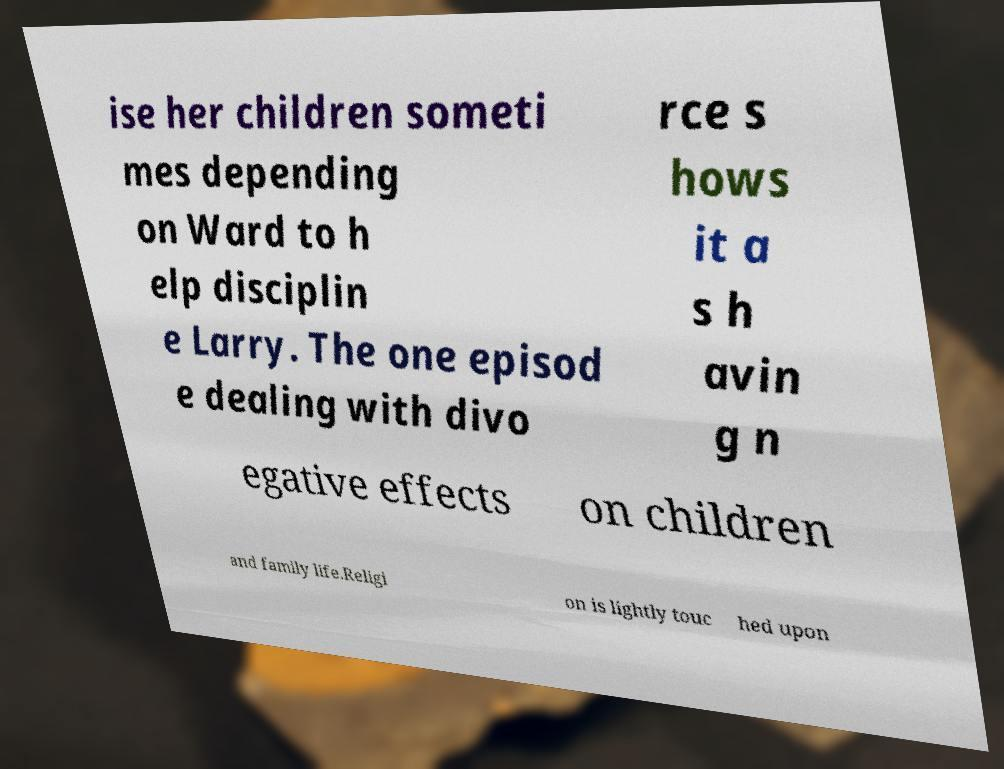For documentation purposes, I need the text within this image transcribed. Could you provide that? ise her children someti mes depending on Ward to h elp disciplin e Larry. The one episod e dealing with divo rce s hows it a s h avin g n egative effects on children and family life.Religi on is lightly touc hed upon 